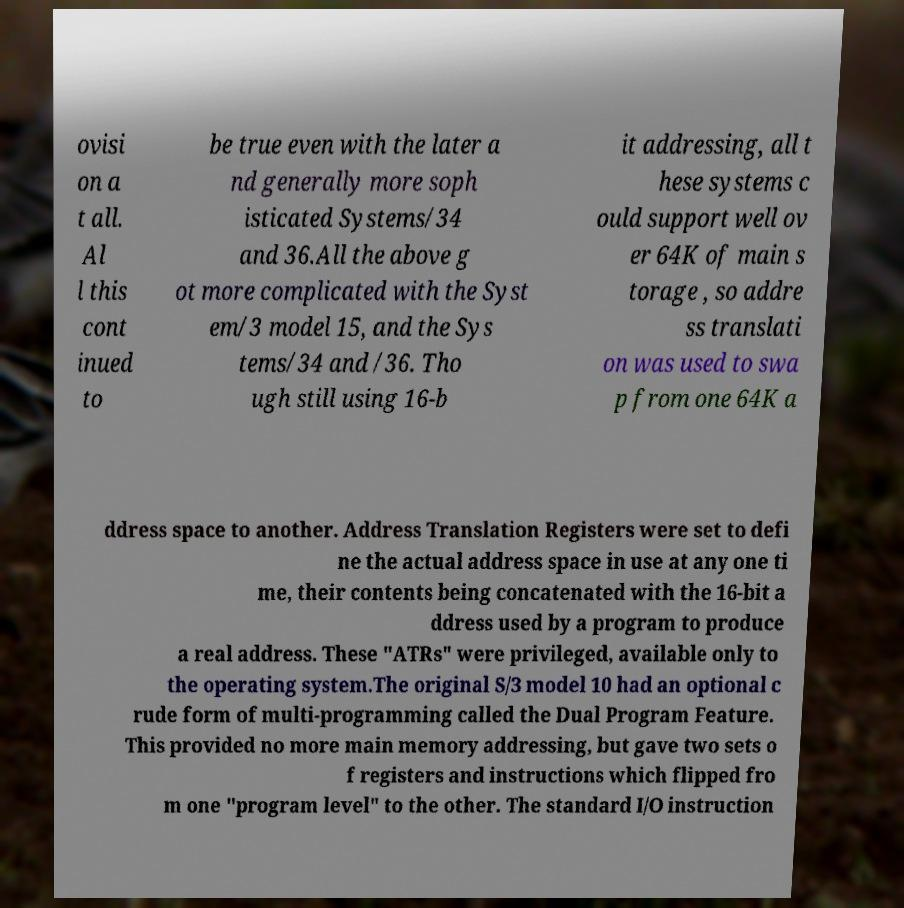I need the written content from this picture converted into text. Can you do that? ovisi on a t all. Al l this cont inued to be true even with the later a nd generally more soph isticated Systems/34 and 36.All the above g ot more complicated with the Syst em/3 model 15, and the Sys tems/34 and /36. Tho ugh still using 16-b it addressing, all t hese systems c ould support well ov er 64K of main s torage , so addre ss translati on was used to swa p from one 64K a ddress space to another. Address Translation Registers were set to defi ne the actual address space in use at any one ti me, their contents being concatenated with the 16-bit a ddress used by a program to produce a real address. These "ATRs" were privileged, available only to the operating system.The original S/3 model 10 had an optional c rude form of multi-programming called the Dual Program Feature. This provided no more main memory addressing, but gave two sets o f registers and instructions which flipped fro m one "program level" to the other. The standard I/O instruction 